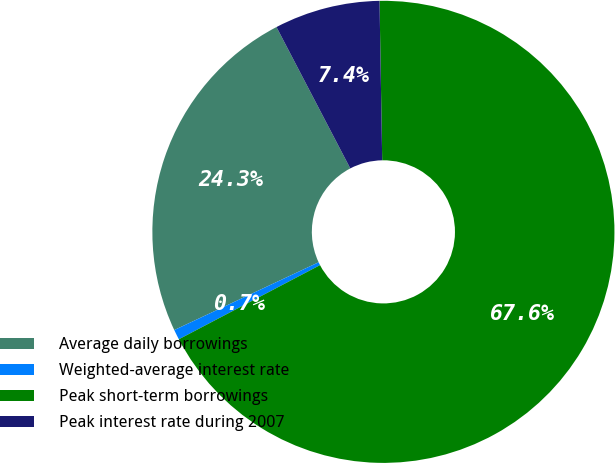<chart> <loc_0><loc_0><loc_500><loc_500><pie_chart><fcel>Average daily borrowings<fcel>Weighted-average interest rate<fcel>Peak short-term borrowings<fcel>Peak interest rate during 2007<nl><fcel>24.33%<fcel>0.71%<fcel>67.57%<fcel>7.39%<nl></chart> 